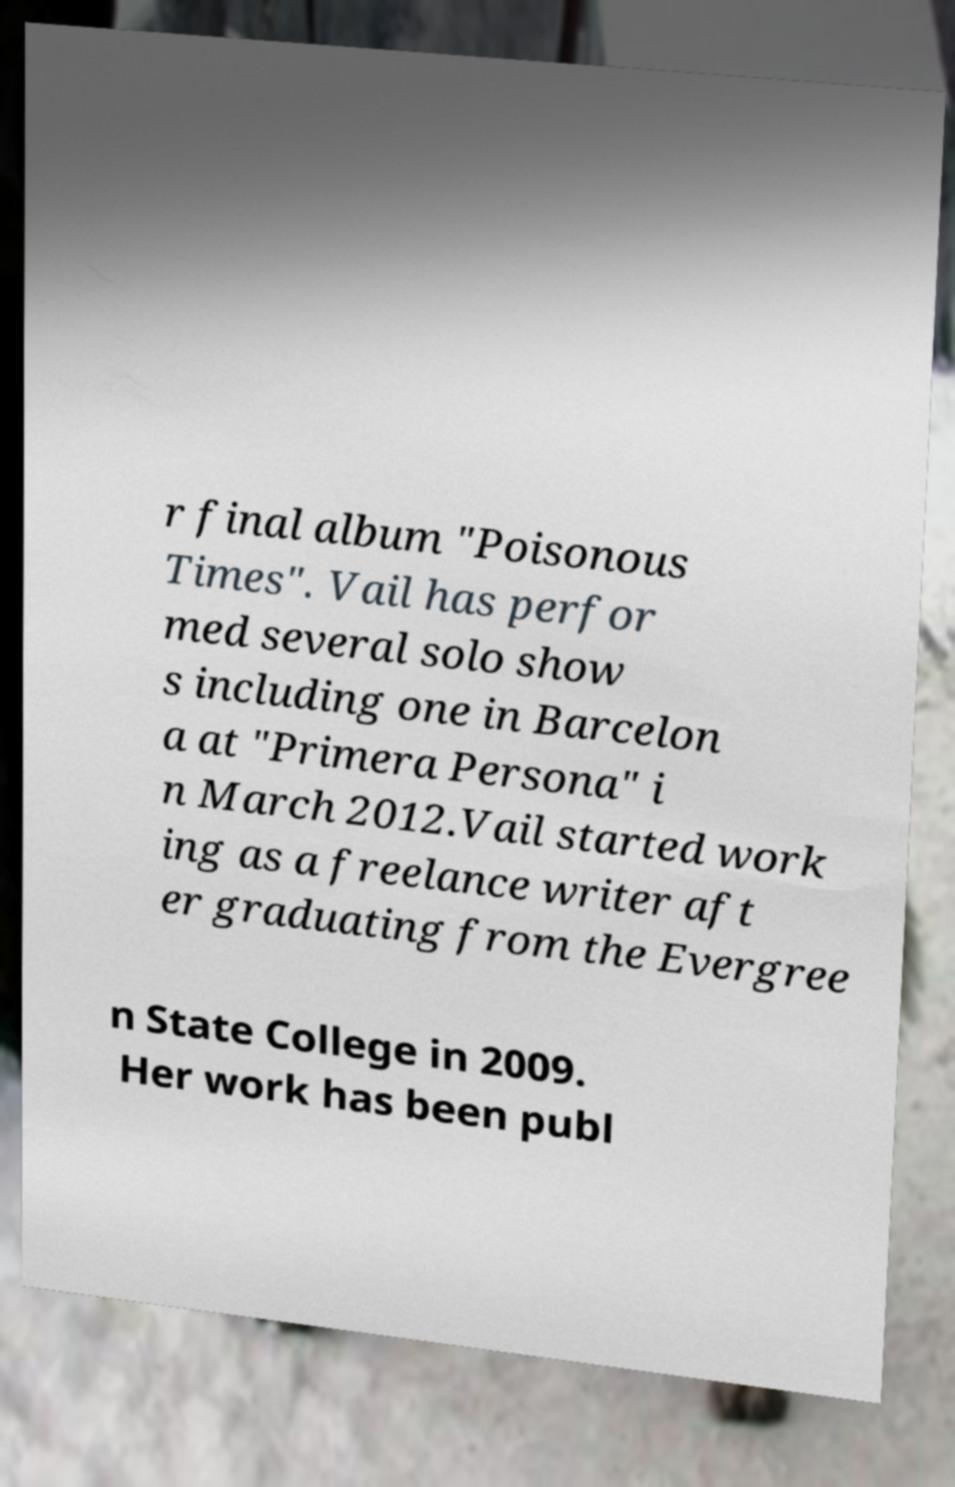What messages or text are displayed in this image? I need them in a readable, typed format. r final album "Poisonous Times". Vail has perfor med several solo show s including one in Barcelon a at "Primera Persona" i n March 2012.Vail started work ing as a freelance writer aft er graduating from the Evergree n State College in 2009. Her work has been publ 